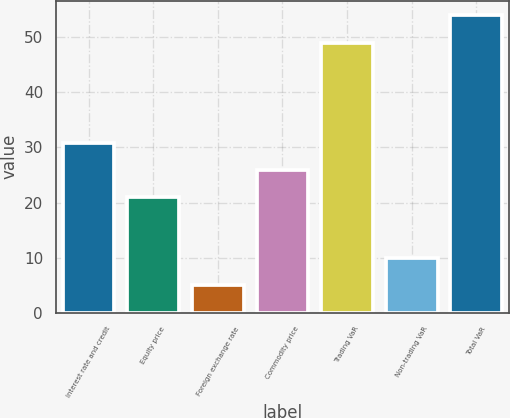Convert chart to OTSL. <chart><loc_0><loc_0><loc_500><loc_500><bar_chart><fcel>Interest rate and credit<fcel>Equity price<fcel>Foreign exchange rate<fcel>Commodity price<fcel>Trading VaR<fcel>Non-trading VaR<fcel>Total VaR<nl><fcel>30.8<fcel>21<fcel>5<fcel>25.9<fcel>49<fcel>10<fcel>54<nl></chart> 